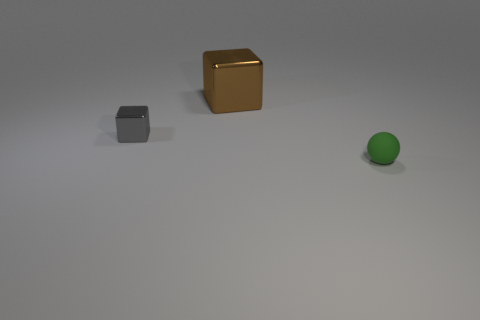Are there more large brown blocks than small purple cylinders?
Give a very brief answer. Yes. There is a tiny gray object that is the same material as the big brown thing; what is its shape?
Your response must be concise. Cube. There is a small object to the right of the metallic block that is on the right side of the tiny gray shiny thing; what is its material?
Ensure brevity in your answer.  Rubber. Is the shape of the object that is in front of the gray block the same as  the brown shiny thing?
Your answer should be very brief. No. Is the number of small objects behind the green object greater than the number of large blue blocks?
Provide a succinct answer. Yes. Is there anything else that is the same material as the small green ball?
Ensure brevity in your answer.  No. What number of cubes are either large gray things or brown things?
Your answer should be compact. 1. What is the color of the thing behind the small object that is behind the small green matte sphere?
Your answer should be very brief. Brown. There is a gray cube that is the same material as the big brown object; what size is it?
Give a very brief answer. Small. There is a tiny object that is in front of the tiny object on the left side of the small green rubber sphere; is there a large brown object left of it?
Keep it short and to the point. Yes. 